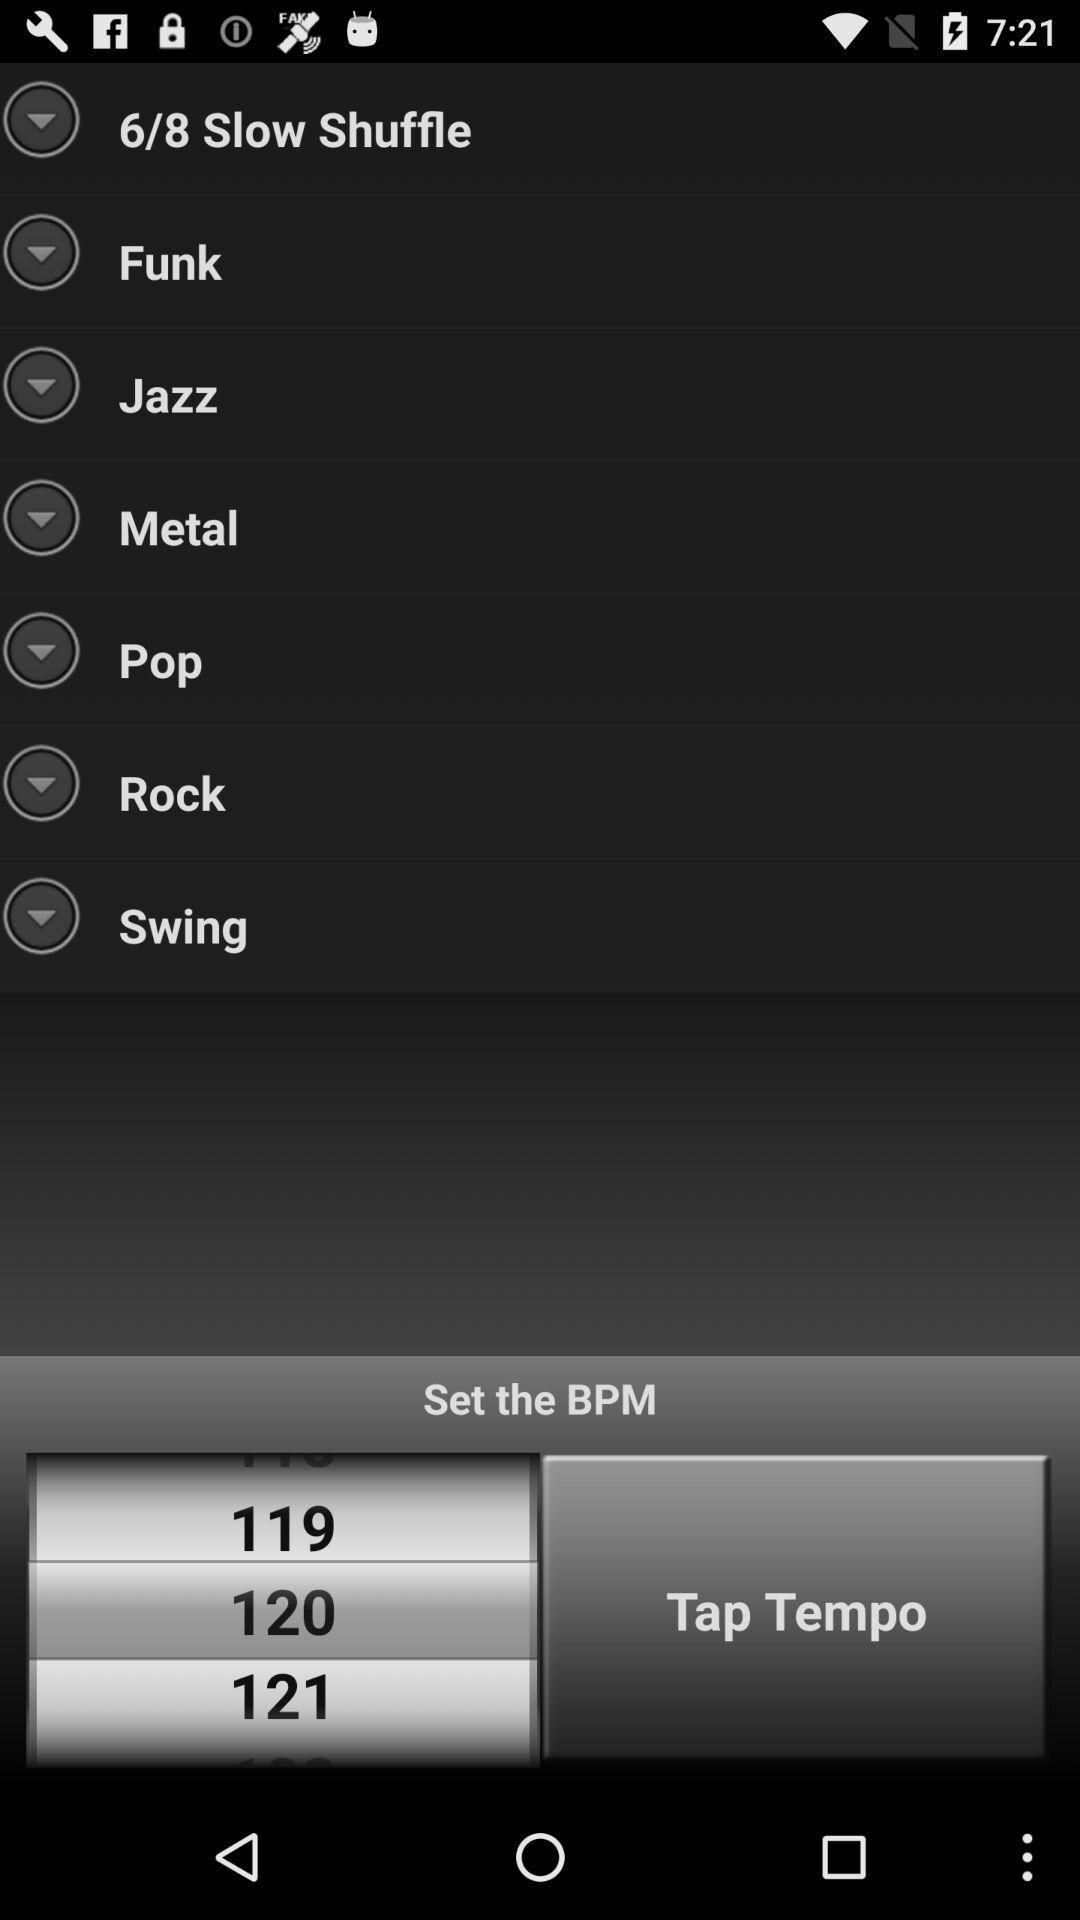What is the selected BPM? The selected BPM is 120. 